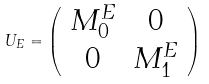Convert formula to latex. <formula><loc_0><loc_0><loc_500><loc_500>U _ { E } = \left ( \begin{array} { c c } M _ { 0 } ^ { E } & 0 \\ 0 & M _ { 1 } ^ { E } \\ \end{array} \right )</formula> 